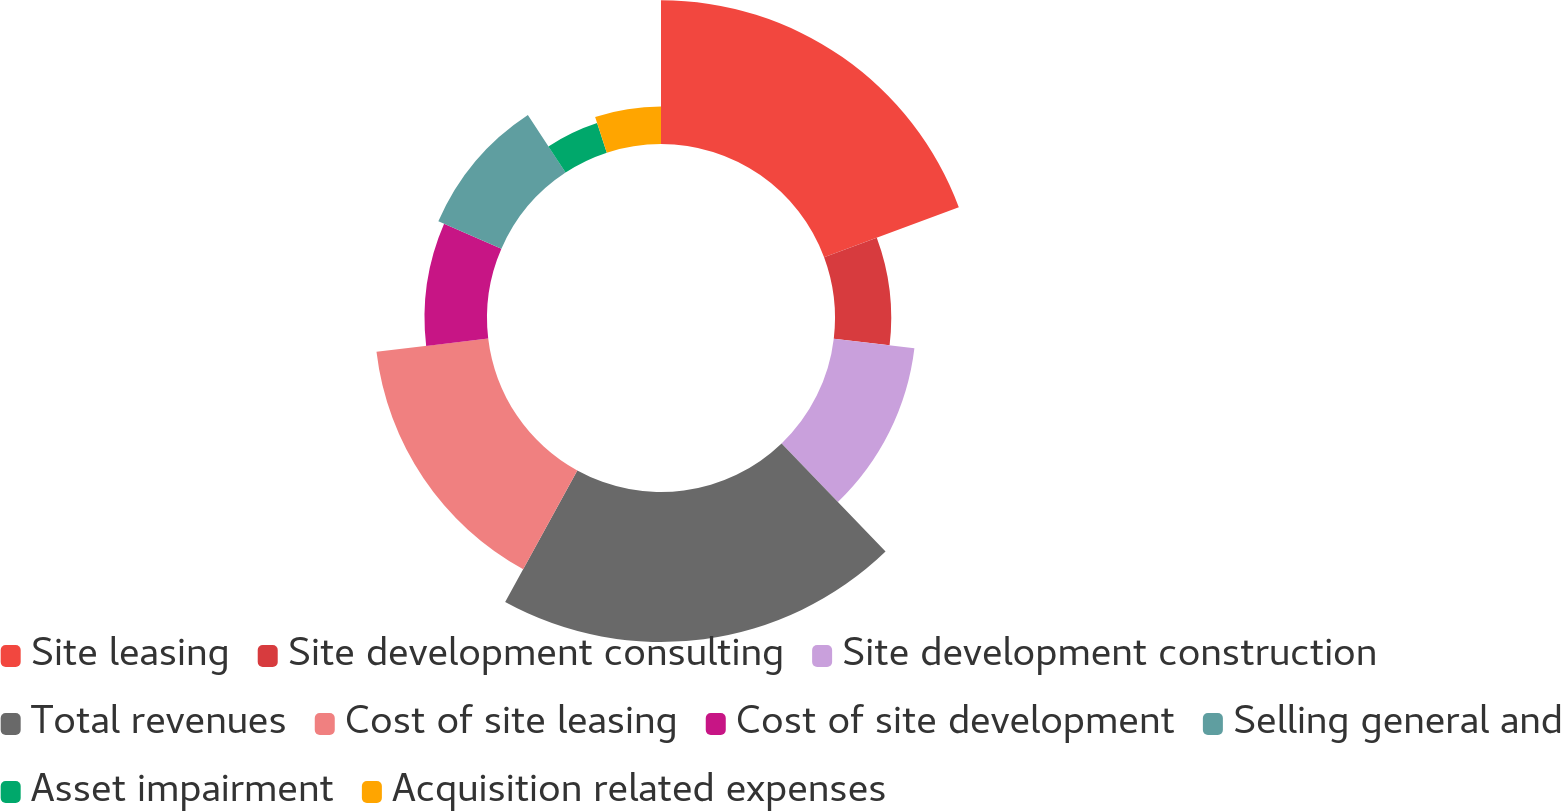Convert chart to OTSL. <chart><loc_0><loc_0><loc_500><loc_500><pie_chart><fcel>Site leasing<fcel>Site development consulting<fcel>Site development construction<fcel>Total revenues<fcel>Cost of site leasing<fcel>Cost of site development<fcel>Selling general and<fcel>Asset impairment<fcel>Acquisition related expenses<nl><fcel>19.33%<fcel>7.56%<fcel>10.92%<fcel>20.17%<fcel>15.13%<fcel>8.4%<fcel>9.24%<fcel>4.2%<fcel>5.04%<nl></chart> 